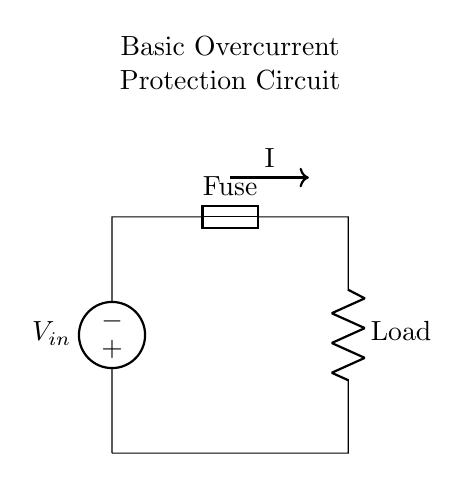What is the input voltage source labeled as? The input voltage source is labeled as V_in, indicating the point where voltage is supplied to the circuit.
Answer: V_in What component is used for overcurrent protection? The component used for overcurrent protection is a fuse, which is designed to disconnect the circuit when the current exceeds a certain threshold.
Answer: Fuse What is the function of the resistor in this circuit? The resistor is labeled as Load, indicating that it serves to limit the current flowing through it under normal operating conditions, effectively acting as the load in the circuit.
Answer: Load What indicates the flow of current in the diagram? The arrow marked I indicates the direction of current flow, which is a standard way to represent current in circuit diagrams.
Answer: I How many components are in series in this circuit? There are two components in series: the fuse and the resistor (Load), both connected end-to-end with the current flowing through them sequentially.
Answer: Two What happens to the fuse when an overcurrent condition occurs? When an overcurrent condition occurs, the fuse will blow or disconnect, interrupting the current flow to protect the circuit components from damage.
Answer: It blows What is the primary purpose of this circuit type? The primary purpose of this circuit type is to provide protection against overcurrent conditions, ensuring that excessive current does not damage components.
Answer: Overcurrent protection 